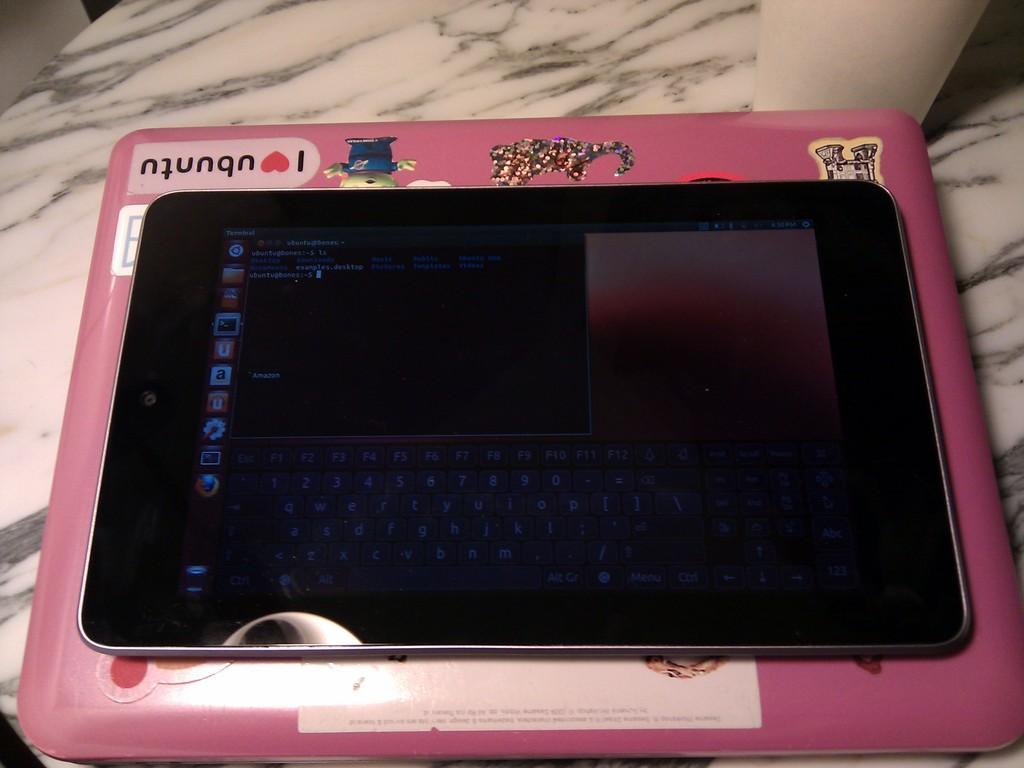How would you summarize this image in a sentence or two? In this picture there is a tab and there is an object on the table and there is a text and there are stickers on the tab. 